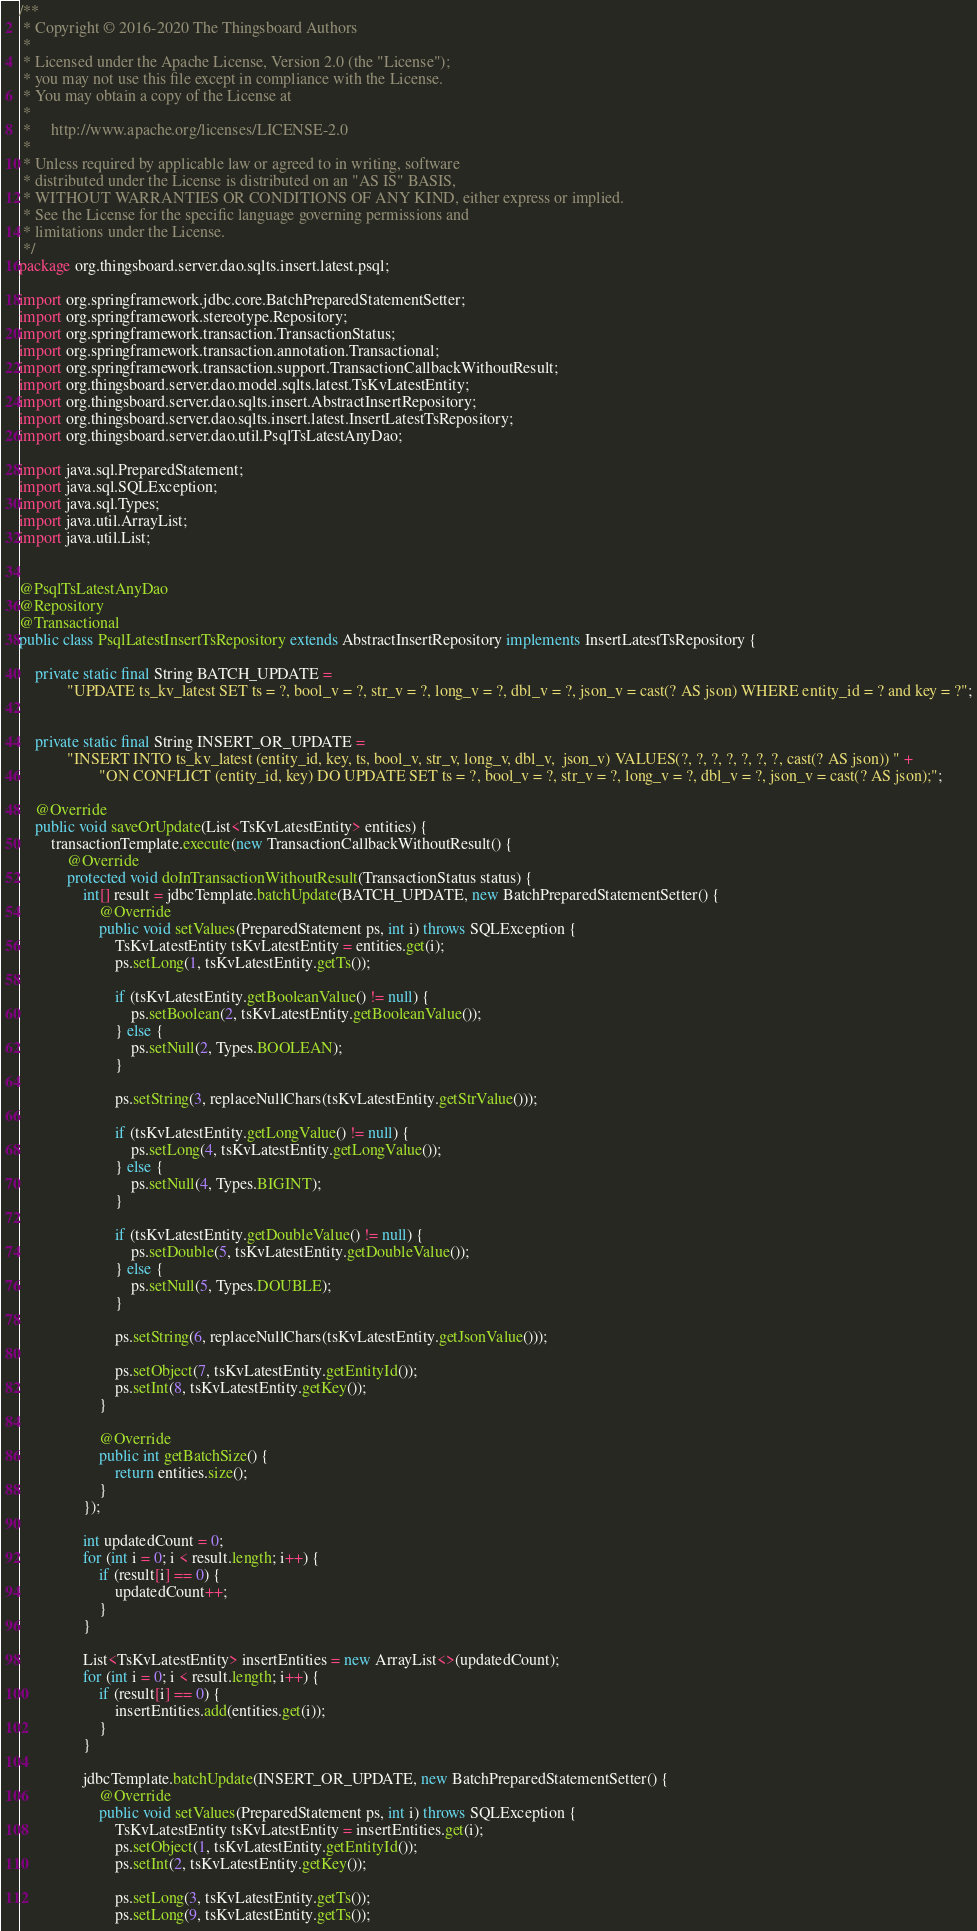Convert code to text. <code><loc_0><loc_0><loc_500><loc_500><_Java_>/**
 * Copyright © 2016-2020 The Thingsboard Authors
 *
 * Licensed under the Apache License, Version 2.0 (the "License");
 * you may not use this file except in compliance with the License.
 * You may obtain a copy of the License at
 *
 *     http://www.apache.org/licenses/LICENSE-2.0
 *
 * Unless required by applicable law or agreed to in writing, software
 * distributed under the License is distributed on an "AS IS" BASIS,
 * WITHOUT WARRANTIES OR CONDITIONS OF ANY KIND, either express or implied.
 * See the License for the specific language governing permissions and
 * limitations under the License.
 */
package org.thingsboard.server.dao.sqlts.insert.latest.psql;

import org.springframework.jdbc.core.BatchPreparedStatementSetter;
import org.springframework.stereotype.Repository;
import org.springframework.transaction.TransactionStatus;
import org.springframework.transaction.annotation.Transactional;
import org.springframework.transaction.support.TransactionCallbackWithoutResult;
import org.thingsboard.server.dao.model.sqlts.latest.TsKvLatestEntity;
import org.thingsboard.server.dao.sqlts.insert.AbstractInsertRepository;
import org.thingsboard.server.dao.sqlts.insert.latest.InsertLatestTsRepository;
import org.thingsboard.server.dao.util.PsqlTsLatestAnyDao;

import java.sql.PreparedStatement;
import java.sql.SQLException;
import java.sql.Types;
import java.util.ArrayList;
import java.util.List;


@PsqlTsLatestAnyDao
@Repository
@Transactional
public class PsqlLatestInsertTsRepository extends AbstractInsertRepository implements InsertLatestTsRepository {

    private static final String BATCH_UPDATE =
            "UPDATE ts_kv_latest SET ts = ?, bool_v = ?, str_v = ?, long_v = ?, dbl_v = ?, json_v = cast(? AS json) WHERE entity_id = ? and key = ?";


    private static final String INSERT_OR_UPDATE =
            "INSERT INTO ts_kv_latest (entity_id, key, ts, bool_v, str_v, long_v, dbl_v,  json_v) VALUES(?, ?, ?, ?, ?, ?, ?, cast(? AS json)) " +
                    "ON CONFLICT (entity_id, key) DO UPDATE SET ts = ?, bool_v = ?, str_v = ?, long_v = ?, dbl_v = ?, json_v = cast(? AS json);";

    @Override
    public void saveOrUpdate(List<TsKvLatestEntity> entities) {
        transactionTemplate.execute(new TransactionCallbackWithoutResult() {
            @Override
            protected void doInTransactionWithoutResult(TransactionStatus status) {
                int[] result = jdbcTemplate.batchUpdate(BATCH_UPDATE, new BatchPreparedStatementSetter() {
                    @Override
                    public void setValues(PreparedStatement ps, int i) throws SQLException {
                        TsKvLatestEntity tsKvLatestEntity = entities.get(i);
                        ps.setLong(1, tsKvLatestEntity.getTs());

                        if (tsKvLatestEntity.getBooleanValue() != null) {
                            ps.setBoolean(2, tsKvLatestEntity.getBooleanValue());
                        } else {
                            ps.setNull(2, Types.BOOLEAN);
                        }

                        ps.setString(3, replaceNullChars(tsKvLatestEntity.getStrValue()));

                        if (tsKvLatestEntity.getLongValue() != null) {
                            ps.setLong(4, tsKvLatestEntity.getLongValue());
                        } else {
                            ps.setNull(4, Types.BIGINT);
                        }

                        if (tsKvLatestEntity.getDoubleValue() != null) {
                            ps.setDouble(5, tsKvLatestEntity.getDoubleValue());
                        } else {
                            ps.setNull(5, Types.DOUBLE);
                        }

                        ps.setString(6, replaceNullChars(tsKvLatestEntity.getJsonValue()));

                        ps.setObject(7, tsKvLatestEntity.getEntityId());
                        ps.setInt(8, tsKvLatestEntity.getKey());
                    }

                    @Override
                    public int getBatchSize() {
                        return entities.size();
                    }
                });

                int updatedCount = 0;
                for (int i = 0; i < result.length; i++) {
                    if (result[i] == 0) {
                        updatedCount++;
                    }
                }

                List<TsKvLatestEntity> insertEntities = new ArrayList<>(updatedCount);
                for (int i = 0; i < result.length; i++) {
                    if (result[i] == 0) {
                        insertEntities.add(entities.get(i));
                    }
                }

                jdbcTemplate.batchUpdate(INSERT_OR_UPDATE, new BatchPreparedStatementSetter() {
                    @Override
                    public void setValues(PreparedStatement ps, int i) throws SQLException {
                        TsKvLatestEntity tsKvLatestEntity = insertEntities.get(i);
                        ps.setObject(1, tsKvLatestEntity.getEntityId());
                        ps.setInt(2, tsKvLatestEntity.getKey());

                        ps.setLong(3, tsKvLatestEntity.getTs());
                        ps.setLong(9, tsKvLatestEntity.getTs());
</code> 